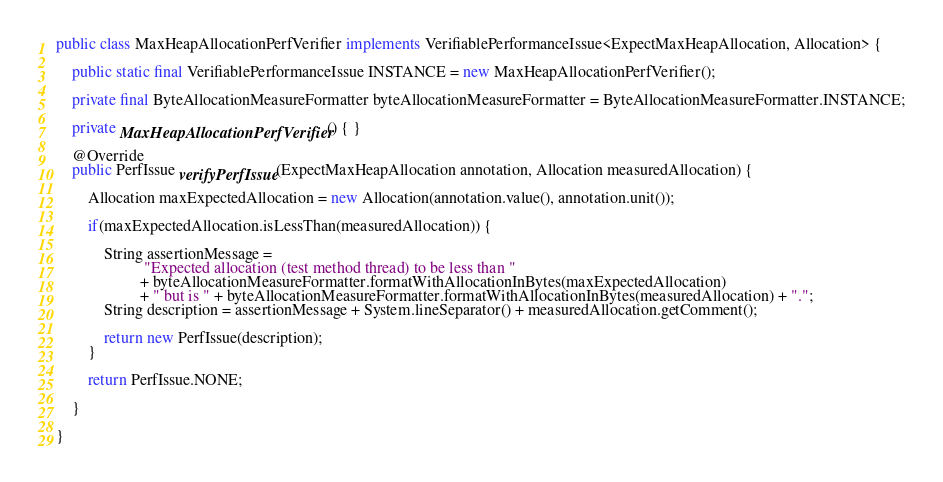Convert code to text. <code><loc_0><loc_0><loc_500><loc_500><_Java_>
public class MaxHeapAllocationPerfVerifier implements VerifiablePerformanceIssue<ExpectMaxHeapAllocation, Allocation> {

    public static final VerifiablePerformanceIssue INSTANCE = new MaxHeapAllocationPerfVerifier();

    private final ByteAllocationMeasureFormatter byteAllocationMeasureFormatter = ByteAllocationMeasureFormatter.INSTANCE;

    private MaxHeapAllocationPerfVerifier() { }

    @Override
    public PerfIssue verifyPerfIssue(ExpectMaxHeapAllocation annotation, Allocation measuredAllocation) {

        Allocation maxExpectedAllocation = new Allocation(annotation.value(), annotation.unit());

        if(maxExpectedAllocation.isLessThan(measuredAllocation)) {

            String assertionMessage =
                      "Expected allocation (test method thread) to be less than "
                     + byteAllocationMeasureFormatter.formatWithAllocationInBytes(maxExpectedAllocation)
                     + " but is " + byteAllocationMeasureFormatter.formatWithAllocationInBytes(measuredAllocation) + ".";
            String description = assertionMessage + System.lineSeparator() + measuredAllocation.getComment();

            return new PerfIssue(description);
        }

        return PerfIssue.NONE;

    }

}
</code> 